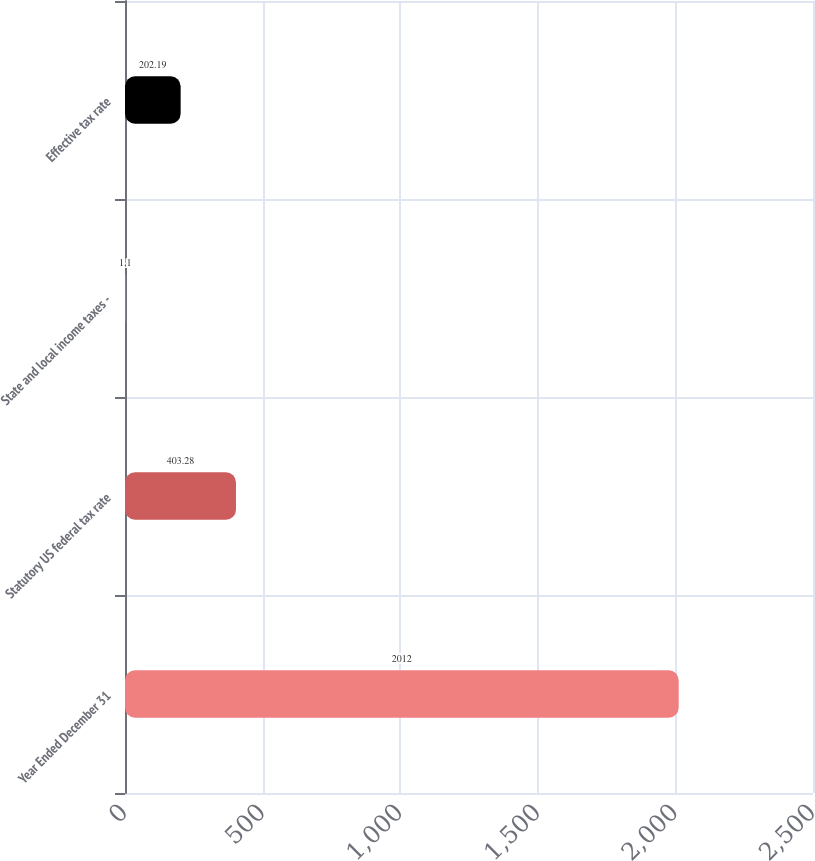Convert chart to OTSL. <chart><loc_0><loc_0><loc_500><loc_500><bar_chart><fcel>Year Ended December 31<fcel>Statutory US federal tax rate<fcel>State and local income taxes -<fcel>Effective tax rate<nl><fcel>2012<fcel>403.28<fcel>1.1<fcel>202.19<nl></chart> 